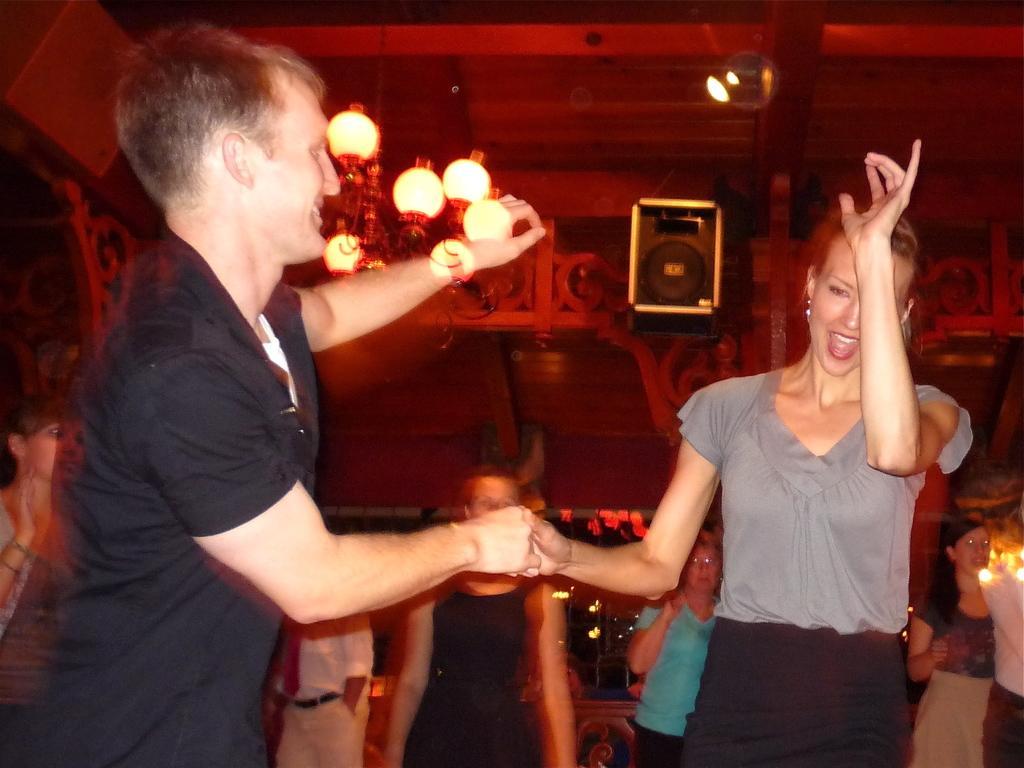Can you describe this image briefly? In this image I can see few people are standing. I can also see few lights and a speaker over there. I can also see this image is little bit blurry. 